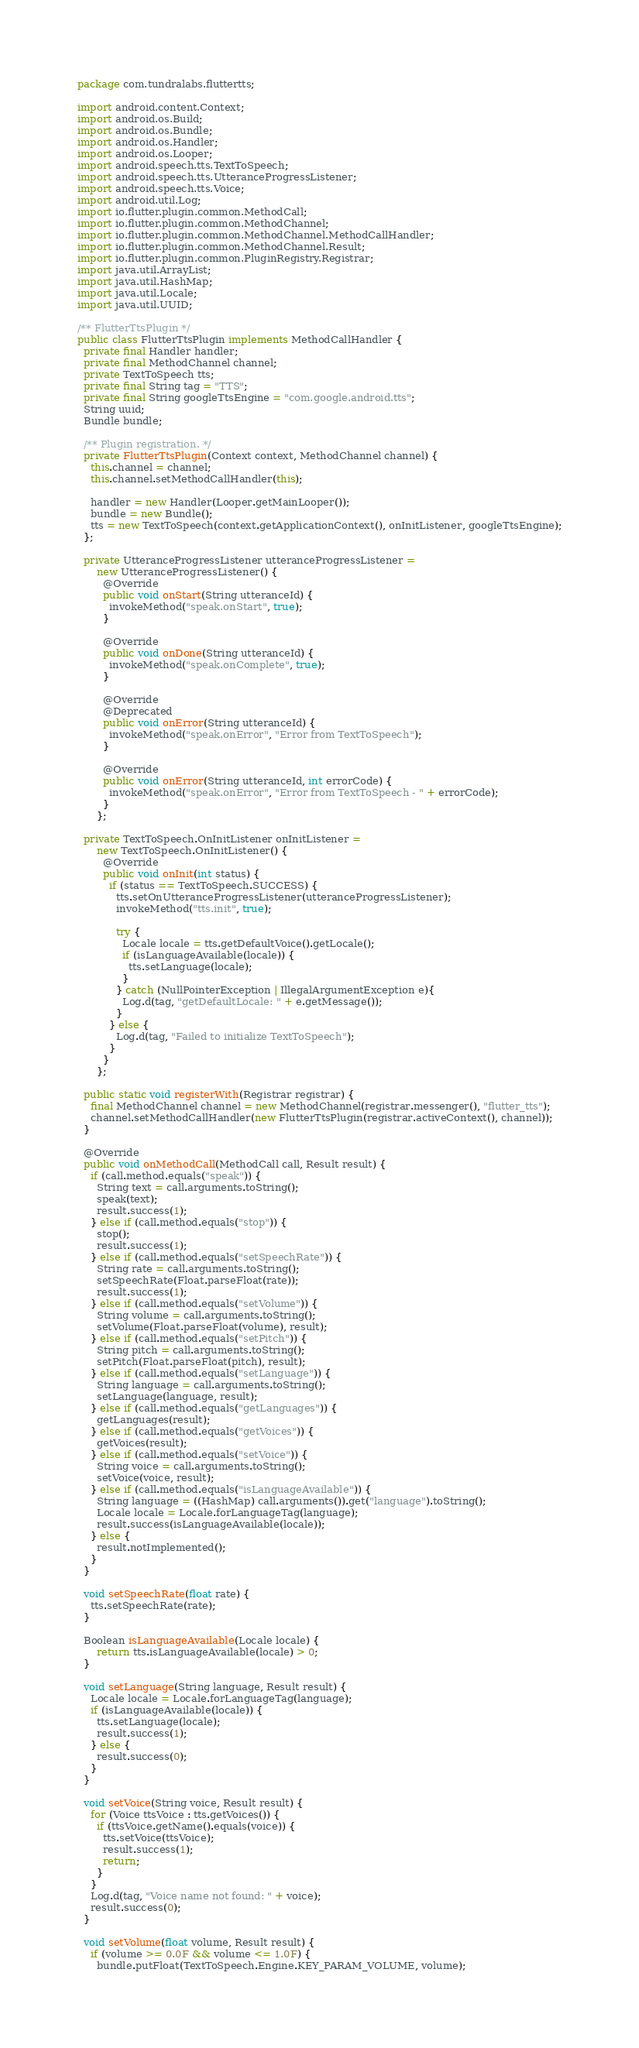<code> <loc_0><loc_0><loc_500><loc_500><_Java_>package com.tundralabs.fluttertts;

import android.content.Context;
import android.os.Build;
import android.os.Bundle;
import android.os.Handler;
import android.os.Looper;
import android.speech.tts.TextToSpeech;
import android.speech.tts.UtteranceProgressListener;
import android.speech.tts.Voice;
import android.util.Log;
import io.flutter.plugin.common.MethodCall;
import io.flutter.plugin.common.MethodChannel;
import io.flutter.plugin.common.MethodChannel.MethodCallHandler;
import io.flutter.plugin.common.MethodChannel.Result;
import io.flutter.plugin.common.PluginRegistry.Registrar;
import java.util.ArrayList;
import java.util.HashMap;
import java.util.Locale;
import java.util.UUID;

/** FlutterTtsPlugin */
public class FlutterTtsPlugin implements MethodCallHandler {
  private final Handler handler;
  private final MethodChannel channel;
  private TextToSpeech tts;
  private final String tag = "TTS";
  private final String googleTtsEngine = "com.google.android.tts";
  String uuid;
  Bundle bundle;

  /** Plugin registration. */
  private FlutterTtsPlugin(Context context, MethodChannel channel) {
    this.channel = channel;
    this.channel.setMethodCallHandler(this);

    handler = new Handler(Looper.getMainLooper());
    bundle = new Bundle();
    tts = new TextToSpeech(context.getApplicationContext(), onInitListener, googleTtsEngine);
  };

  private UtteranceProgressListener utteranceProgressListener =
      new UtteranceProgressListener() {
        @Override
        public void onStart(String utteranceId) {
          invokeMethod("speak.onStart", true);
        }

        @Override
        public void onDone(String utteranceId) {
          invokeMethod("speak.onComplete", true);
        }

        @Override
        @Deprecated
        public void onError(String utteranceId) {
          invokeMethod("speak.onError", "Error from TextToSpeech");
        }

        @Override
        public void onError(String utteranceId, int errorCode) {
          invokeMethod("speak.onError", "Error from TextToSpeech - " + errorCode);
        }
      };

  private TextToSpeech.OnInitListener onInitListener =
      new TextToSpeech.OnInitListener() {
        @Override
        public void onInit(int status) {
          if (status == TextToSpeech.SUCCESS) {
            tts.setOnUtteranceProgressListener(utteranceProgressListener);
            invokeMethod("tts.init", true);

            try {
              Locale locale = tts.getDefaultVoice().getLocale();
              if (isLanguageAvailable(locale)) {
                tts.setLanguage(locale);
              }
            } catch (NullPointerException | IllegalArgumentException e){
              Log.d(tag, "getDefaultLocale: " + e.getMessage());
            }
          } else {
            Log.d(tag, "Failed to initialize TextToSpeech");
          }
        }
      };

  public static void registerWith(Registrar registrar) {
    final MethodChannel channel = new MethodChannel(registrar.messenger(), "flutter_tts");
    channel.setMethodCallHandler(new FlutterTtsPlugin(registrar.activeContext(), channel));
  }

  @Override
  public void onMethodCall(MethodCall call, Result result) {
    if (call.method.equals("speak")) {
      String text = call.arguments.toString();
      speak(text);
      result.success(1);
    } else if (call.method.equals("stop")) {
      stop();
      result.success(1);
    } else if (call.method.equals("setSpeechRate")) {
      String rate = call.arguments.toString();
      setSpeechRate(Float.parseFloat(rate));
      result.success(1);
    } else if (call.method.equals("setVolume")) {
      String volume = call.arguments.toString();
      setVolume(Float.parseFloat(volume), result);
    } else if (call.method.equals("setPitch")) {
      String pitch = call.arguments.toString();
      setPitch(Float.parseFloat(pitch), result);
    } else if (call.method.equals("setLanguage")) {
      String language = call.arguments.toString();
      setLanguage(language, result);
    } else if (call.method.equals("getLanguages")) {
      getLanguages(result);
    } else if (call.method.equals("getVoices")) {
      getVoices(result);
    } else if (call.method.equals("setVoice")) {
      String voice = call.arguments.toString();
      setVoice(voice, result);
    } else if (call.method.equals("isLanguageAvailable")) {
      String language = ((HashMap) call.arguments()).get("language").toString();
      Locale locale = Locale.forLanguageTag(language);
      result.success(isLanguageAvailable(locale));
    } else {
      result.notImplemented();
    }
  }

  void setSpeechRate(float rate) {
    tts.setSpeechRate(rate);
  }

  Boolean isLanguageAvailable(Locale locale) {
      return tts.isLanguageAvailable(locale) > 0;
  }

  void setLanguage(String language, Result result) {
    Locale locale = Locale.forLanguageTag(language);
    if (isLanguageAvailable(locale)) {
      tts.setLanguage(locale);
      result.success(1);
    } else {
      result.success(0);
    }
  }

  void setVoice(String voice, Result result) {
    for (Voice ttsVoice : tts.getVoices()) {
      if (ttsVoice.getName().equals(voice)) {
        tts.setVoice(ttsVoice);
        result.success(1);
        return;
      }
    }
    Log.d(tag, "Voice name not found: " + voice);
    result.success(0);
  }

  void setVolume(float volume, Result result) {
    if (volume >= 0.0F && volume <= 1.0F) {
      bundle.putFloat(TextToSpeech.Engine.KEY_PARAM_VOLUME, volume);</code> 